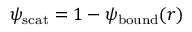<formula> <loc_0><loc_0><loc_500><loc_500>\psi _ { s c a t } = 1 - \psi _ { b o u n d } ( r )</formula> 